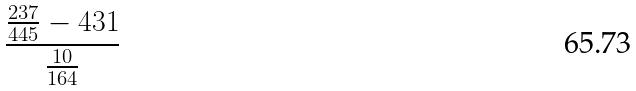<formula> <loc_0><loc_0><loc_500><loc_500>\frac { \frac { 2 3 7 } { 4 4 5 } - 4 3 1 } { \frac { 1 0 } { 1 6 4 } }</formula> 